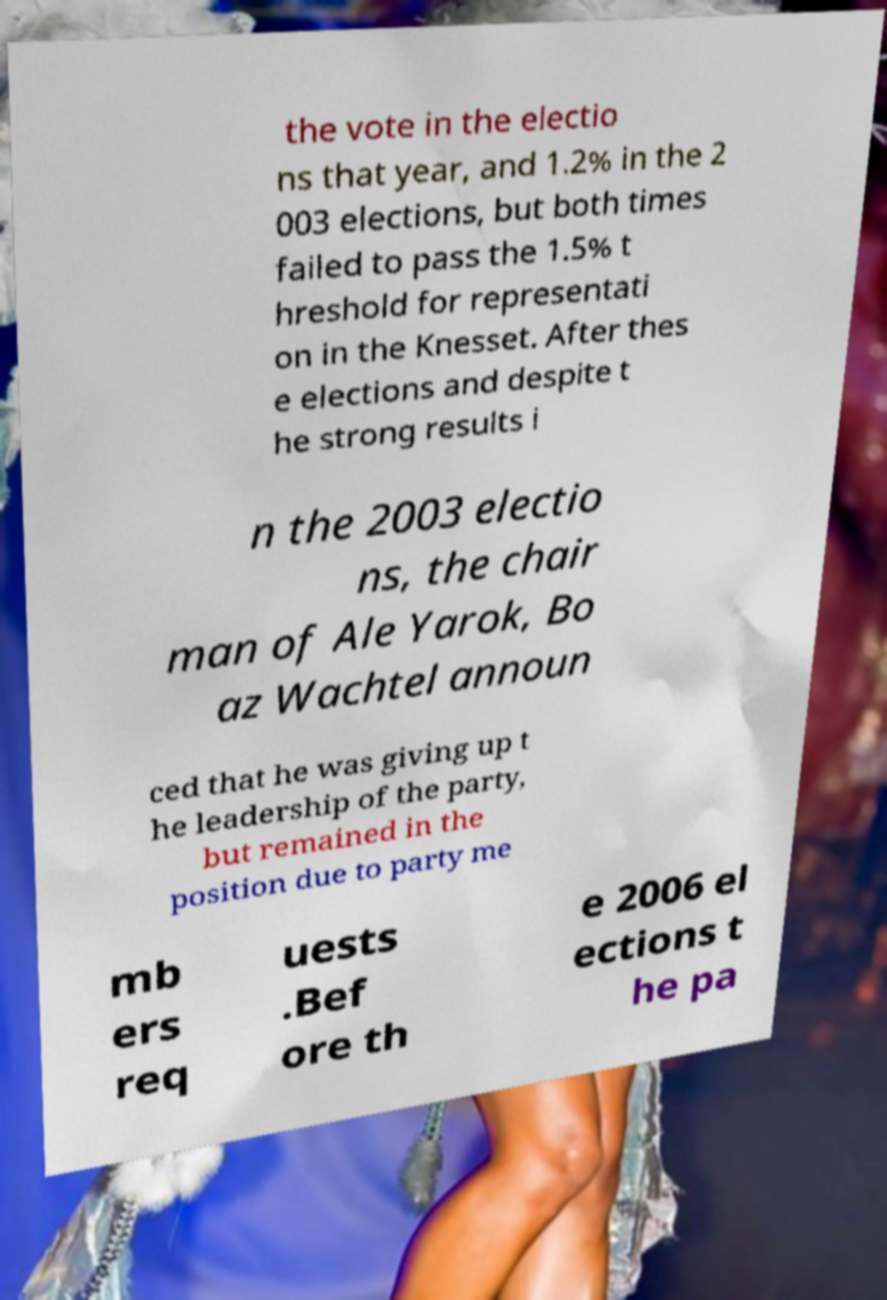Could you assist in decoding the text presented in this image and type it out clearly? the vote in the electio ns that year, and 1.2% in the 2 003 elections, but both times failed to pass the 1.5% t hreshold for representati on in the Knesset. After thes e elections and despite t he strong results i n the 2003 electio ns, the chair man of Ale Yarok, Bo az Wachtel announ ced that he was giving up t he leadership of the party, but remained in the position due to party me mb ers req uests .Bef ore th e 2006 el ections t he pa 